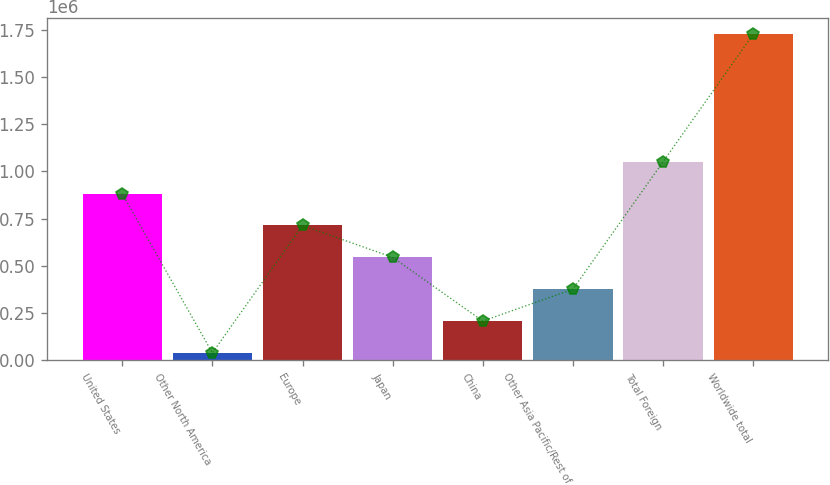Convert chart. <chart><loc_0><loc_0><loc_500><loc_500><bar_chart><fcel>United States<fcel>Other North America<fcel>Europe<fcel>Japan<fcel>China<fcel>Other Asia Pacific/Rest of<fcel>Total Foreign<fcel>Worldwide total<nl><fcel>882162<fcel>38074<fcel>713344<fcel>544527<fcel>206892<fcel>375709<fcel>1.05098e+06<fcel>1.72625e+06<nl></chart> 